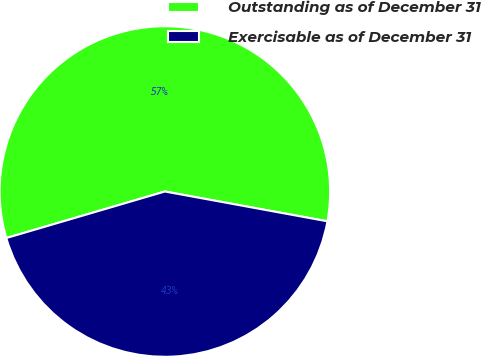Convert chart to OTSL. <chart><loc_0><loc_0><loc_500><loc_500><pie_chart><fcel>Outstanding as of December 31<fcel>Exercisable as of December 31<nl><fcel>57.43%<fcel>42.57%<nl></chart> 